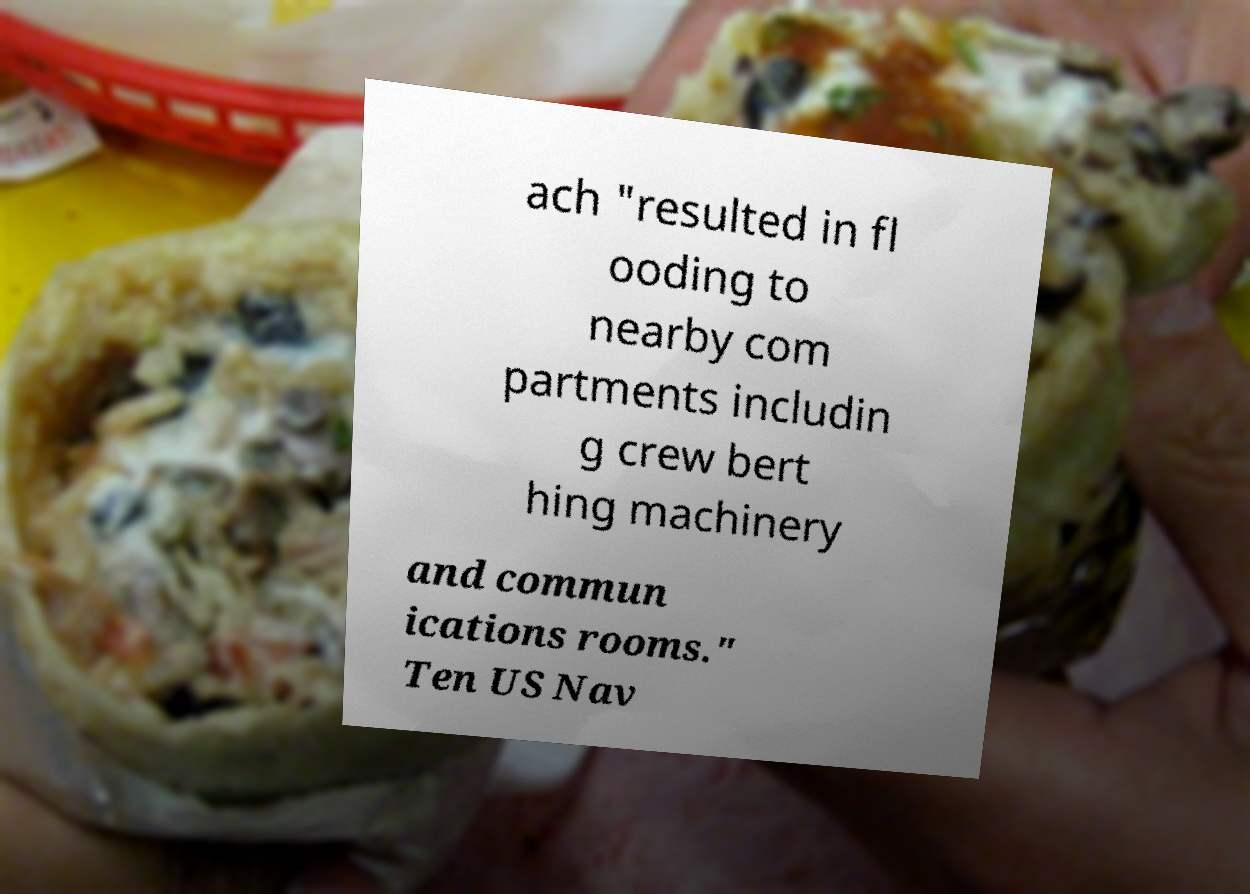Can you read and provide the text displayed in the image?This photo seems to have some interesting text. Can you extract and type it out for me? ach "resulted in fl ooding to nearby com partments includin g crew bert hing machinery and commun ications rooms." Ten US Nav 